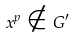Convert formula to latex. <formula><loc_0><loc_0><loc_500><loc_500>x ^ { p } \notin G ^ { \prime }</formula> 